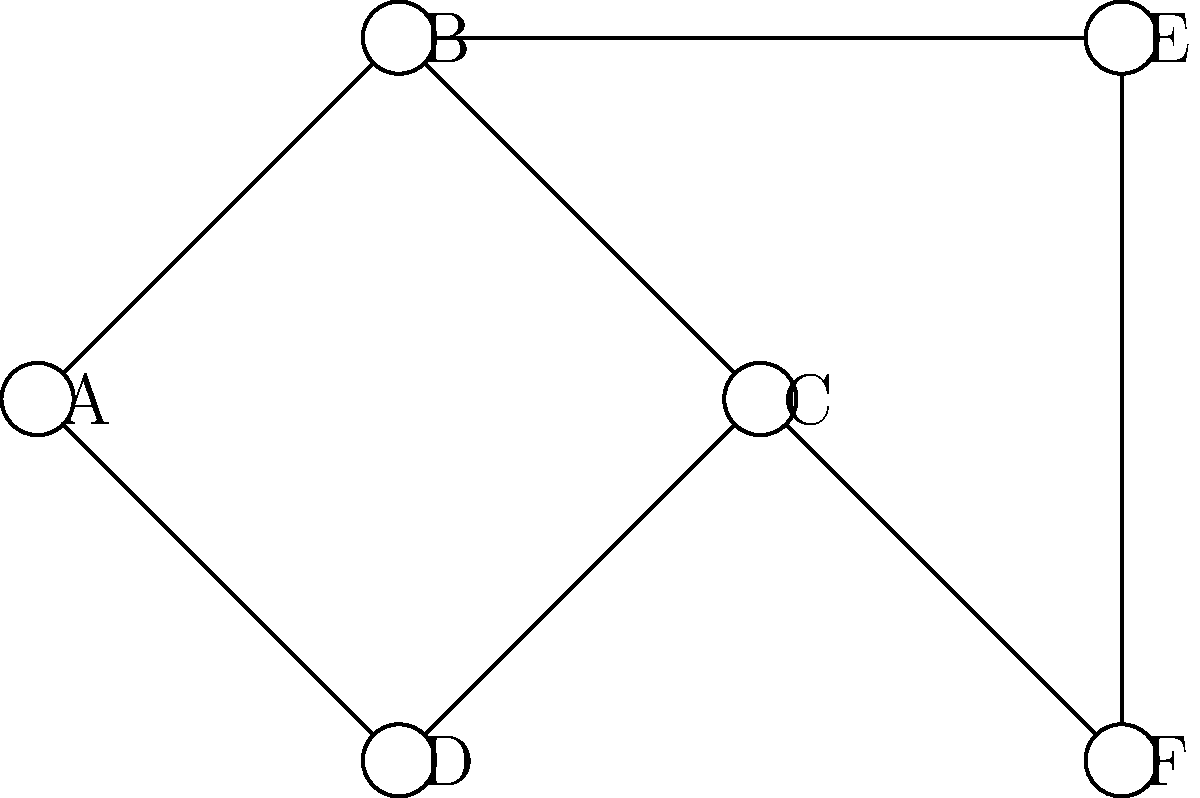In the network topology shown above, which node's removal would cause the most significant disruption to the overall connectivity, potentially leading to accessibility issues for users? To determine which node's removal would cause the most significant disruption, we need to analyze the network topology and consider each node's importance:

1. Node A: Connected to B and D. Removal would affect 2 connections.
2. Node B: Connected to A, C, and E. Removal would affect 3 connections.
3. Node C: Connected to B, D, and F. Removal would affect 3 connections.
4. Node D: Connected to A and C. Removal would affect 2 connections.
5. Node E: Connected to B and F. Removal would affect 2 connections.
6. Node F: Connected to C and E. Removal would affect 2 connections.

Nodes B and C have the most connections (3 each). However, node C is more critical because:
1. It connects the left side of the network (A, B, D) to the right side (E, F).
2. Its removal would completely isolate node F from the rest of the network.
3. It forms part of the central "backbone" of the network (B-C-F).

Therefore, removing node C would cause the most significant disruption to the overall connectivity, potentially leading to the most severe accessibility issues for users.
Answer: Node C 